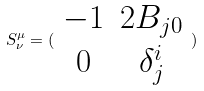Convert formula to latex. <formula><loc_0><loc_0><loc_500><loc_500>S _ { \nu } ^ { \mu } = ( \begin{array} { c c } - 1 & 2 B _ { j 0 } \\ 0 & \delta _ { j } ^ { i } \end{array} )</formula> 